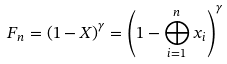Convert formula to latex. <formula><loc_0><loc_0><loc_500><loc_500>F _ { n } = \left ( 1 - X \right ) ^ { \gamma } = \left ( 1 - \bigoplus _ { i = 1 } ^ { n } x _ { i } \right ) ^ { \gamma }</formula> 